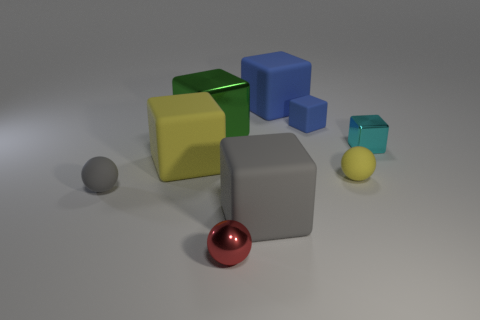What materials do the objects in the image appear to be made from? The objects in the image appear to be made from different materials. The cubes and the large sphere seem to have matte finishes suggesting they could be made of plastic or painted wood, while the small gray sphere and red sphere have shiny surfaces that are indicative of metallic materials.  Is there any significance to the arrangement of the shapes? While the arrangement of shapes in this image might not have an explicit significance, it does create a visually balanced composition. The placement of the shapes might be designed to showcase contrast in colors and sizes, or to illustrate concepts of geometry and spatial relationships in a simple, aesthetically pleasing way. 